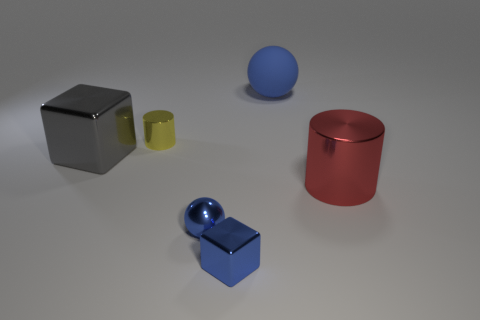Add 3 red objects. How many objects exist? 9 Subtract all balls. How many objects are left? 4 Subtract all small blue things. Subtract all big gray blocks. How many objects are left? 3 Add 1 tiny yellow metal things. How many tiny yellow metal things are left? 2 Add 1 gray objects. How many gray objects exist? 2 Subtract 0 purple cubes. How many objects are left? 6 